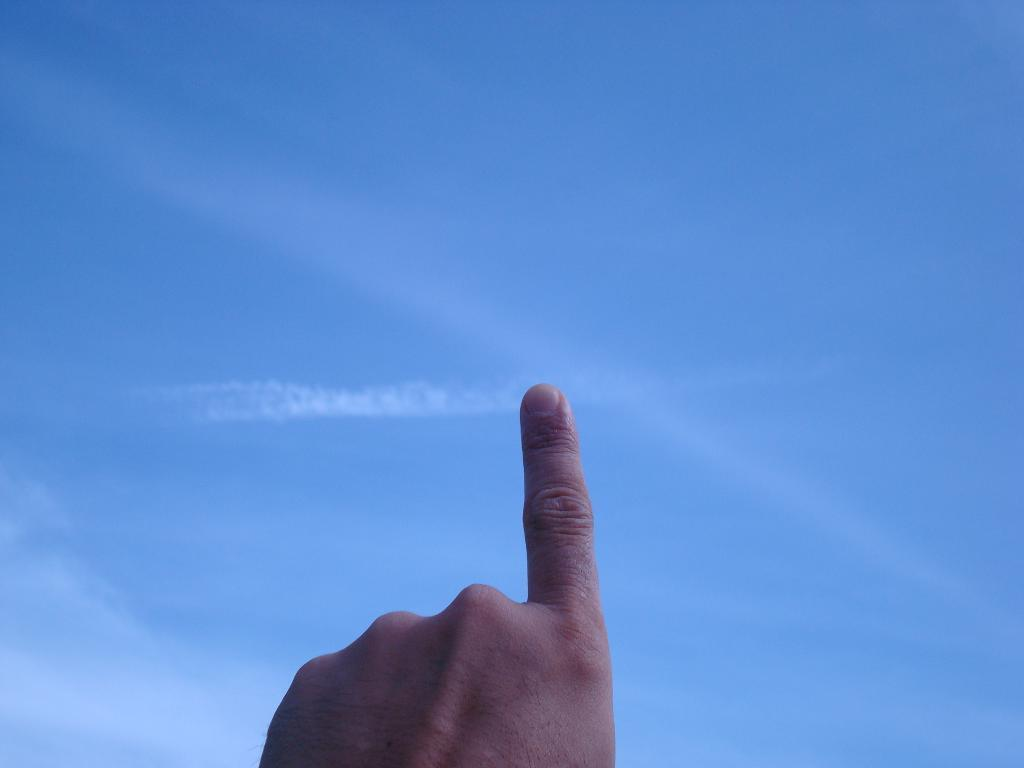What is the person's hand doing in the image? There is a person's hand pointing towards the sky in the image. What type of furniture is being traded in the image? There is no furniture or trade activity present in the image; it only features a person's hand pointing towards the sky. 